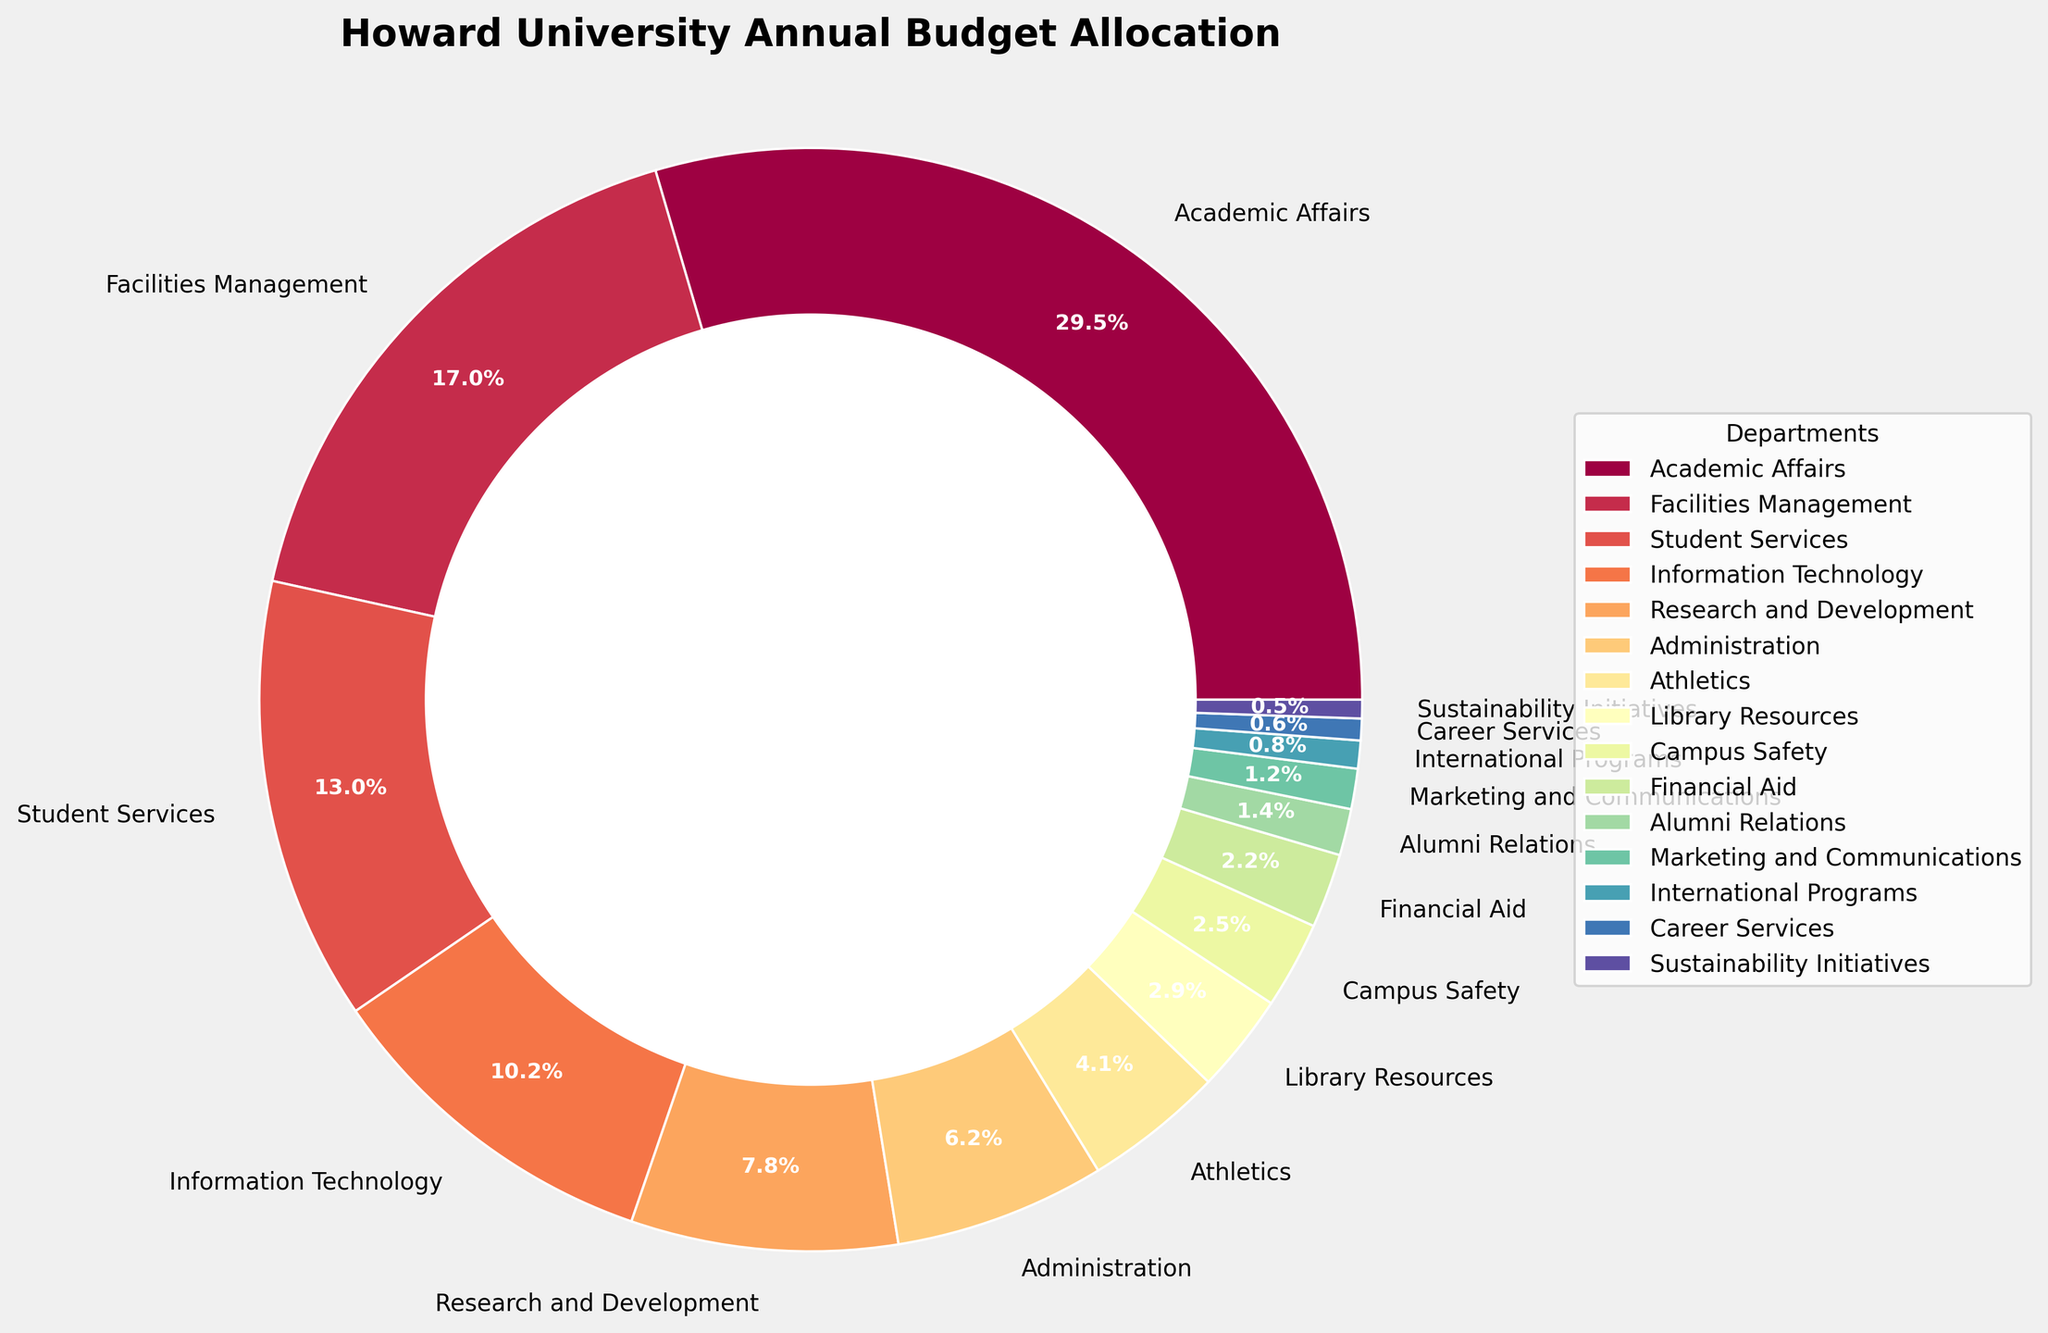Which department has the highest budget allocation? By visually inspecting the pie chart, the largest slice corresponds to Academic Affairs.
Answer: Academic Affairs Which two departments combined have a budget allocation of over 40%? The slices for Academic Affairs (32.5%) and Facilities Management (18.7%) added together equal 51.2%.
Answer: Academic Affairs and Facilities Management Is the budget allocated to Facilities Management greater than the combined allocation for Student Services and Information Technology? Facilities Management has 18.7%, while Student Services has 14.3% and Information Technology has 11.2%, summing up to 25.5%. Thus, Facilities Management's allocation is not greater.
Answer: No Are there any departments with a budget allocation under 1%? The slices for International Programs (0.9%), Career Services (0.7%), and Sustainability Initiatives (0.6%) all have allocations under 1%.
Answer: Yes What is the total budget allocation for the three smallest departments? Adding the allocations of International Programs (0.9%), Career Services (0.7%), and Sustainability Initiatives (0.6%) gives 0.9% + 0.7% + 0.6% = 2.2%.
Answer: 2.2% How does the budget allocation for Athletics compare to that of Research and Development? Visually, the slice for Research and Development (8.6%) is significantly larger than Athletics (4.5%).
Answer: Research and Development has a higher allocation What is the average budget allocation per department? Sum all the budget allocations for the 15 departments, which equals 100%, and divide by the number of departments: 100% / 15 = 6.67%.
Answer: 6.67% Which department has a budget allocation closest to 5%? By visually inspecting the pie chart, Athletics has an allocation of 4.5%, which is closest to 5%.
Answer: Athletics Are Student Services and Library Resources combined budget allocations more or less than 20%? Student Services has 14.3%, and Library Resources has 3.2%. Adding these gives 17.5%, which is less than 20%.
Answer: Less 